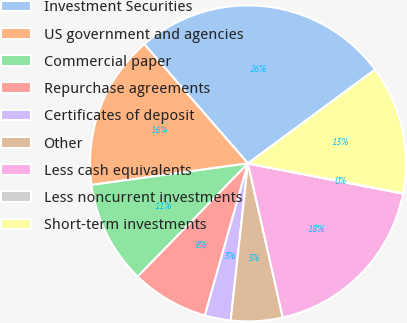Convert chart to OTSL. <chart><loc_0><loc_0><loc_500><loc_500><pie_chart><fcel>Investment Securities<fcel>US government and agencies<fcel>Commercial paper<fcel>Repurchase agreements<fcel>Certificates of deposit<fcel>Other<fcel>Less cash equivalents<fcel>Less noncurrent investments<fcel>Short-term investments<nl><fcel>26.27%<fcel>15.78%<fcel>10.53%<fcel>7.9%<fcel>2.65%<fcel>5.28%<fcel>18.4%<fcel>0.03%<fcel>13.15%<nl></chart> 